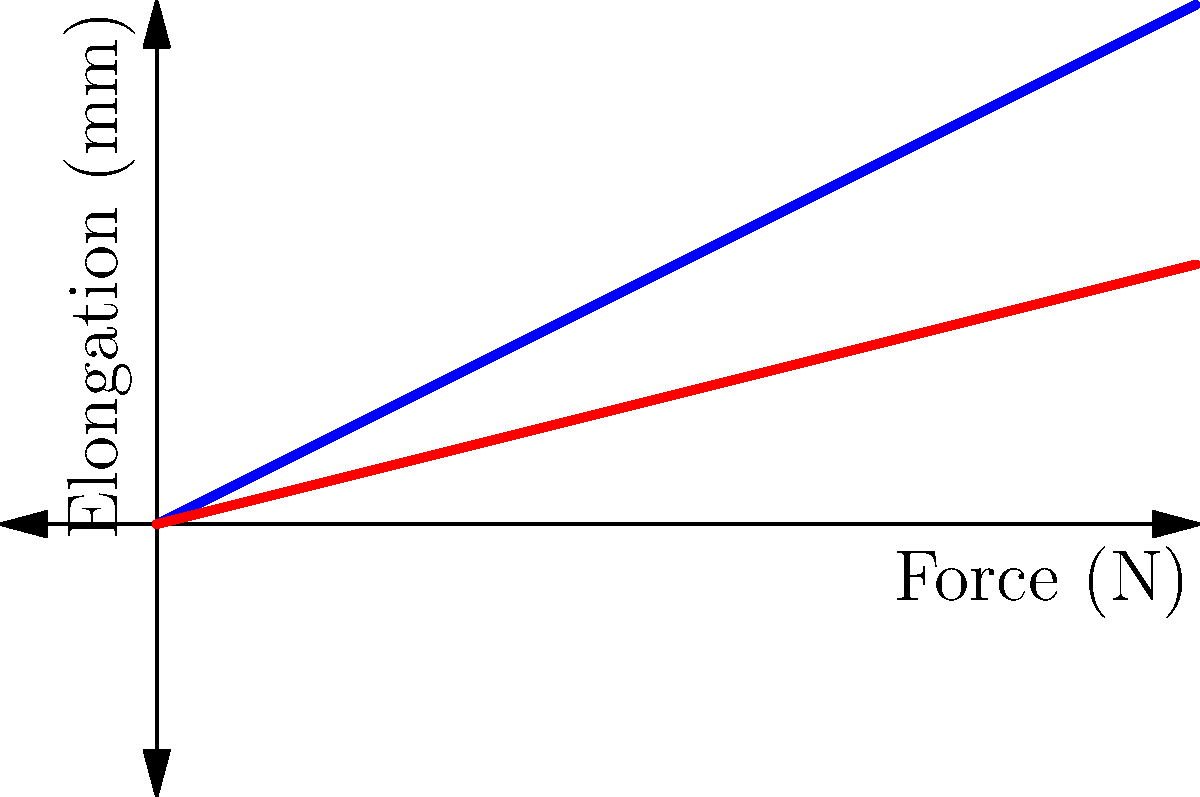As a magician father, you're designing a collapsible wand for your next trick. You have two materials to choose from, represented by the stress-strain curves above. Which material would be more suitable for a prop that needs to withstand sudden forces without breaking, and why? To determine which material is more suitable for a collapsible wand that needs to withstand sudden forces, we need to analyze the stress-strain curves provided:

1. Interpret the graph:
   - The x-axis represents the applied force (stress) in Newtons (N).
   - The y-axis represents the elongation (strain) in millimeters (mm).
   - Blue line (Material A) has a steeper slope.
   - Red line (Material B) has a gentler slope.

2. Understand material properties:
   - The slope of each line represents the material's stiffness (Young's modulus, $E$).
   - $E = \frac{\text{stress}}{\text{strain}} = \frac{\text{force} / \text{area}}{\text{elongation} / \text{original length}}$

3. Compare the materials:
   - Material A (blue) has a steeper slope, indicating higher stiffness.
   - Material B (red) has a lower slope, indicating lower stiffness and higher flexibility.

4. Consider the application:
   - A collapsible wand needs to be flexible enough to collapse without breaking.
   - It also needs to withstand sudden forces during the trick.

5. Analyze material behavior:
   - Material A will resist deformation more but may be prone to sudden failure under high stress.
   - Material B will deform more easily, absorbing energy and reducing the risk of sudden failure.

6. Make a decision:
   - For a collapsible prop that needs to withstand sudden forces, Material B (red line) is more suitable.
   - It offers greater flexibility and energy absorption, reducing the risk of breakage during the magic trick.
Answer: Material B (red line), due to higher flexibility and energy absorption. 